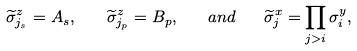<formula> <loc_0><loc_0><loc_500><loc_500>\widetilde { \sigma } _ { j _ { s } } ^ { z } = A _ { s } , \quad \widetilde { \sigma } _ { j _ { p } } ^ { z } = B _ { p } , \quad a n d \quad \widetilde { \sigma } _ { j } ^ { x } = \prod _ { j > i } \sigma _ { i } ^ { y } ,</formula> 